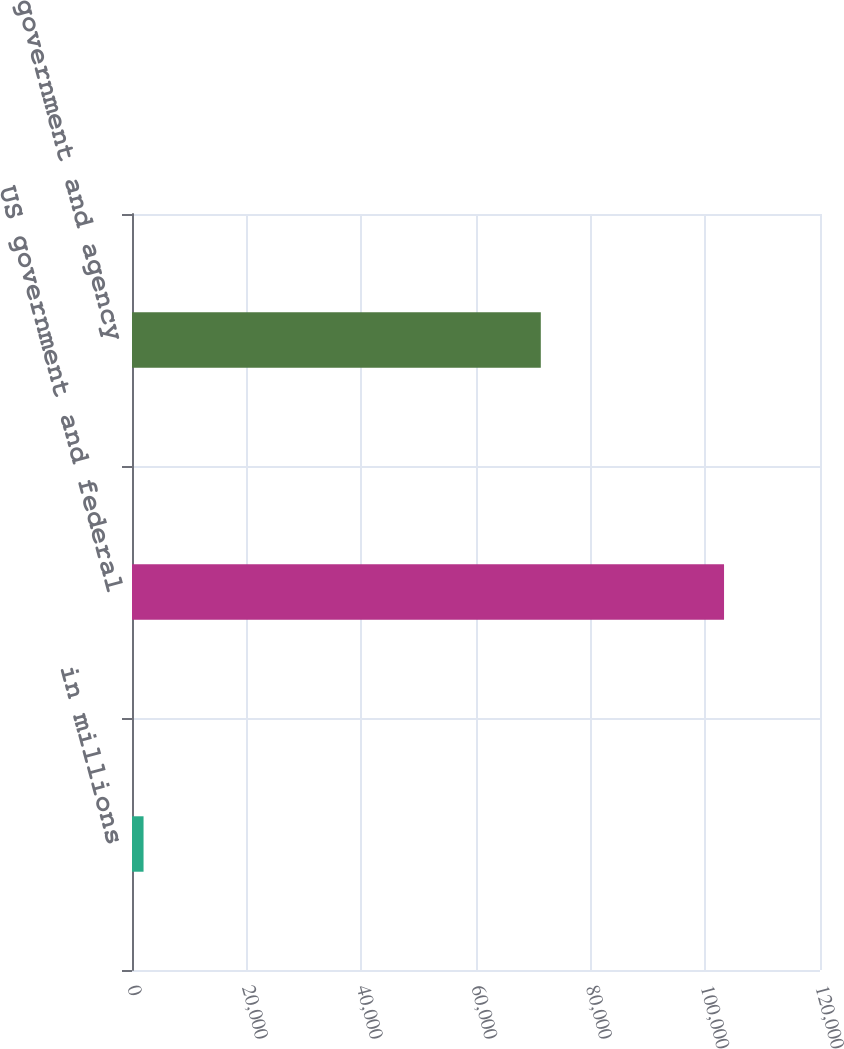<chart> <loc_0><loc_0><loc_500><loc_500><bar_chart><fcel>in millions<fcel>US government and federal<fcel>Non-US government and agency<nl><fcel>2014<fcel>103263<fcel>71302<nl></chart> 